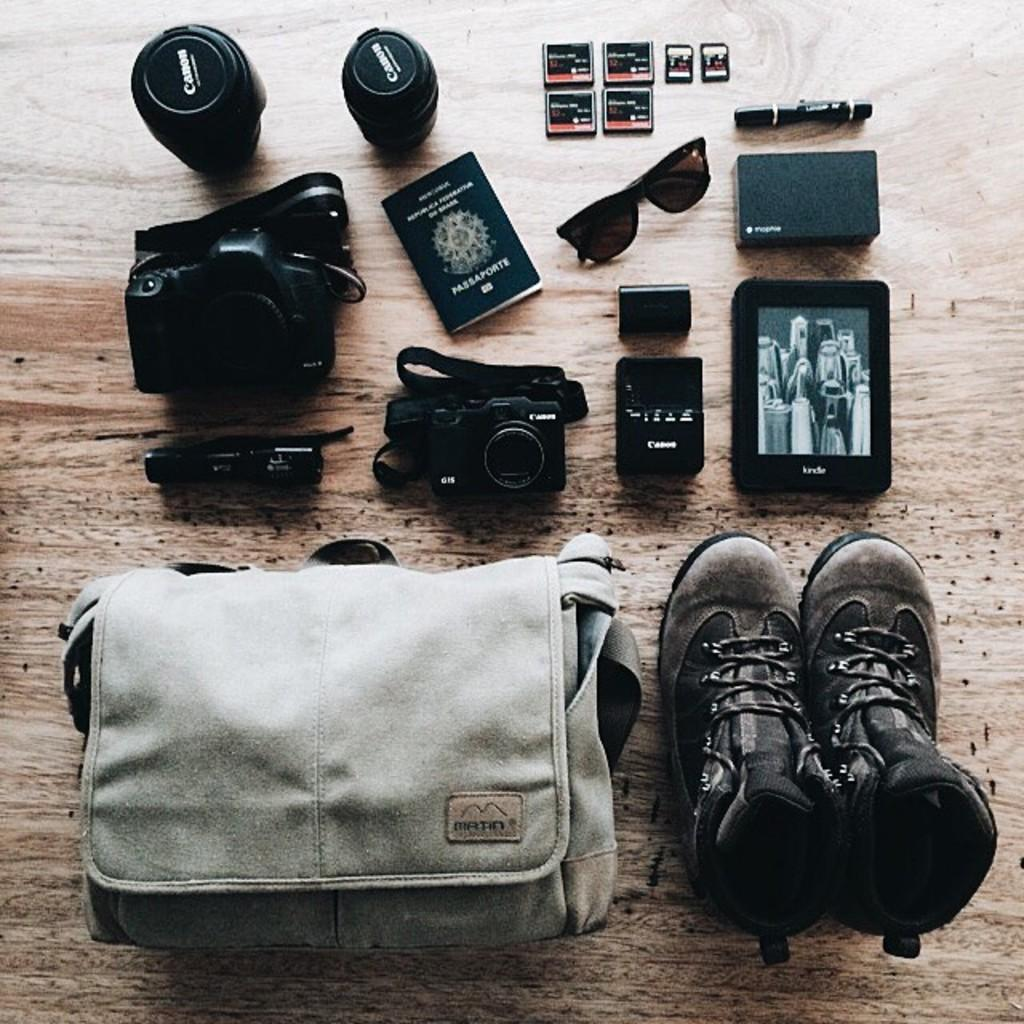What type of object can be seen in the image that people often use to carry items? There is a bag in the image that people often use to carry items. What type of footwear is visible in the image? There are shoes in the image. What device is used for capturing images in the image? There is a camera in the image. What type of eyewear is present in the image? There are spectacles in the image. What writing instrument is visible in the image? There is a pen in the image. What type of object is used for reading or learning in the image? There is a book in the image. On what surface are all the objects placed in the image? All the objects are kept on a wooden table in the image. What type of insect can be seen crawling on the wooden table in the image? There is no insect present in the image, including a ladybug. What type of vehicle is flying in the image? There is no vehicle present in the image, including a plane. 